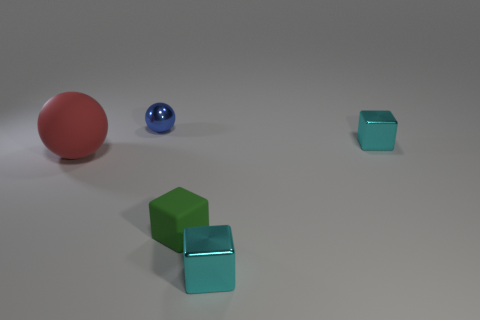There is a tiny metallic thing in front of the big red ball; is its color the same as the shiny sphere?
Your response must be concise. No. What number of blue metallic objects are the same size as the blue ball?
Provide a short and direct response. 0. What is the shape of the large object that is made of the same material as the green cube?
Offer a very short reply. Sphere. Is there a rubber thing of the same color as the large ball?
Your response must be concise. No. What material is the tiny blue sphere?
Your answer should be very brief. Metal. How many objects are small cyan blocks or tiny rubber objects?
Make the answer very short. 3. What size is the sphere that is behind the rubber sphere?
Ensure brevity in your answer.  Small. What number of other things are there of the same material as the tiny blue sphere
Make the answer very short. 2. Is there a tiny metallic object in front of the ball that is on the right side of the big ball?
Provide a short and direct response. Yes. Is there anything else that has the same shape as the green thing?
Your answer should be compact. Yes. 